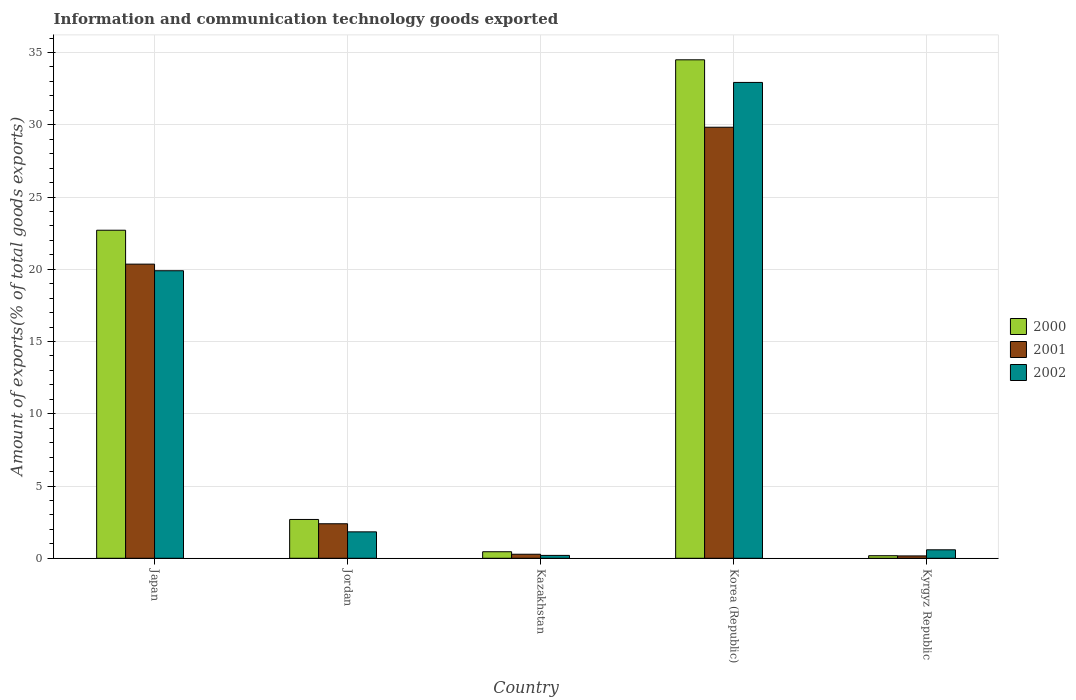What is the label of the 5th group of bars from the left?
Offer a terse response. Kyrgyz Republic. What is the amount of goods exported in 2002 in Kyrgyz Republic?
Give a very brief answer. 0.59. Across all countries, what is the maximum amount of goods exported in 2001?
Give a very brief answer. 29.83. Across all countries, what is the minimum amount of goods exported in 2001?
Your answer should be compact. 0.16. In which country was the amount of goods exported in 2001 maximum?
Offer a terse response. Korea (Republic). In which country was the amount of goods exported in 2001 minimum?
Make the answer very short. Kyrgyz Republic. What is the total amount of goods exported in 2001 in the graph?
Your response must be concise. 53.01. What is the difference between the amount of goods exported in 2001 in Kazakhstan and that in Korea (Republic)?
Ensure brevity in your answer.  -29.55. What is the difference between the amount of goods exported in 2002 in Kazakhstan and the amount of goods exported in 2001 in Korea (Republic)?
Provide a succinct answer. -29.63. What is the average amount of goods exported in 2002 per country?
Provide a short and direct response. 11.09. What is the difference between the amount of goods exported of/in 2002 and amount of goods exported of/in 2001 in Kyrgyz Republic?
Provide a succinct answer. 0.42. What is the ratio of the amount of goods exported in 2002 in Japan to that in Kazakhstan?
Give a very brief answer. 99.92. Is the difference between the amount of goods exported in 2002 in Japan and Jordan greater than the difference between the amount of goods exported in 2001 in Japan and Jordan?
Keep it short and to the point. Yes. What is the difference between the highest and the second highest amount of goods exported in 2000?
Keep it short and to the point. 31.81. What is the difference between the highest and the lowest amount of goods exported in 2000?
Keep it short and to the point. 34.32. In how many countries, is the amount of goods exported in 2002 greater than the average amount of goods exported in 2002 taken over all countries?
Keep it short and to the point. 2. What does the 1st bar from the left in Kazakhstan represents?
Provide a succinct answer. 2000. What does the 1st bar from the right in Japan represents?
Your answer should be compact. 2002. How many bars are there?
Give a very brief answer. 15. How many countries are there in the graph?
Your answer should be compact. 5. Are the values on the major ticks of Y-axis written in scientific E-notation?
Your answer should be very brief. No. Does the graph contain any zero values?
Your response must be concise. No. Does the graph contain grids?
Make the answer very short. Yes. Where does the legend appear in the graph?
Provide a short and direct response. Center right. What is the title of the graph?
Your response must be concise. Information and communication technology goods exported. What is the label or title of the Y-axis?
Provide a short and direct response. Amount of exports(% of total goods exports). What is the Amount of exports(% of total goods exports) of 2000 in Japan?
Offer a very short reply. 22.7. What is the Amount of exports(% of total goods exports) of 2001 in Japan?
Keep it short and to the point. 20.36. What is the Amount of exports(% of total goods exports) of 2002 in Japan?
Your response must be concise. 19.9. What is the Amount of exports(% of total goods exports) in 2000 in Jordan?
Your response must be concise. 2.69. What is the Amount of exports(% of total goods exports) of 2001 in Jordan?
Your answer should be compact. 2.39. What is the Amount of exports(% of total goods exports) of 2002 in Jordan?
Keep it short and to the point. 1.83. What is the Amount of exports(% of total goods exports) of 2000 in Kazakhstan?
Keep it short and to the point. 0.45. What is the Amount of exports(% of total goods exports) of 2001 in Kazakhstan?
Offer a terse response. 0.28. What is the Amount of exports(% of total goods exports) in 2002 in Kazakhstan?
Offer a very short reply. 0.2. What is the Amount of exports(% of total goods exports) in 2000 in Korea (Republic)?
Give a very brief answer. 34.5. What is the Amount of exports(% of total goods exports) of 2001 in Korea (Republic)?
Provide a short and direct response. 29.83. What is the Amount of exports(% of total goods exports) in 2002 in Korea (Republic)?
Your response must be concise. 32.93. What is the Amount of exports(% of total goods exports) of 2000 in Kyrgyz Republic?
Your response must be concise. 0.18. What is the Amount of exports(% of total goods exports) of 2001 in Kyrgyz Republic?
Keep it short and to the point. 0.16. What is the Amount of exports(% of total goods exports) of 2002 in Kyrgyz Republic?
Keep it short and to the point. 0.59. Across all countries, what is the maximum Amount of exports(% of total goods exports) in 2000?
Make the answer very short. 34.5. Across all countries, what is the maximum Amount of exports(% of total goods exports) in 2001?
Your answer should be very brief. 29.83. Across all countries, what is the maximum Amount of exports(% of total goods exports) of 2002?
Ensure brevity in your answer.  32.93. Across all countries, what is the minimum Amount of exports(% of total goods exports) of 2000?
Ensure brevity in your answer.  0.18. Across all countries, what is the minimum Amount of exports(% of total goods exports) in 2001?
Your answer should be very brief. 0.16. Across all countries, what is the minimum Amount of exports(% of total goods exports) in 2002?
Your answer should be very brief. 0.2. What is the total Amount of exports(% of total goods exports) of 2000 in the graph?
Ensure brevity in your answer.  60.51. What is the total Amount of exports(% of total goods exports) in 2001 in the graph?
Make the answer very short. 53.01. What is the total Amount of exports(% of total goods exports) in 2002 in the graph?
Give a very brief answer. 55.44. What is the difference between the Amount of exports(% of total goods exports) in 2000 in Japan and that in Jordan?
Offer a terse response. 20.02. What is the difference between the Amount of exports(% of total goods exports) of 2001 in Japan and that in Jordan?
Give a very brief answer. 17.97. What is the difference between the Amount of exports(% of total goods exports) in 2002 in Japan and that in Jordan?
Your response must be concise. 18.07. What is the difference between the Amount of exports(% of total goods exports) of 2000 in Japan and that in Kazakhstan?
Give a very brief answer. 22.25. What is the difference between the Amount of exports(% of total goods exports) in 2001 in Japan and that in Kazakhstan?
Give a very brief answer. 20.08. What is the difference between the Amount of exports(% of total goods exports) of 2002 in Japan and that in Kazakhstan?
Keep it short and to the point. 19.7. What is the difference between the Amount of exports(% of total goods exports) in 2000 in Japan and that in Korea (Republic)?
Your answer should be very brief. -11.79. What is the difference between the Amount of exports(% of total goods exports) in 2001 in Japan and that in Korea (Republic)?
Provide a short and direct response. -9.47. What is the difference between the Amount of exports(% of total goods exports) in 2002 in Japan and that in Korea (Republic)?
Make the answer very short. -13.03. What is the difference between the Amount of exports(% of total goods exports) of 2000 in Japan and that in Kyrgyz Republic?
Keep it short and to the point. 22.53. What is the difference between the Amount of exports(% of total goods exports) of 2001 in Japan and that in Kyrgyz Republic?
Provide a short and direct response. 20.19. What is the difference between the Amount of exports(% of total goods exports) of 2002 in Japan and that in Kyrgyz Republic?
Your response must be concise. 19.31. What is the difference between the Amount of exports(% of total goods exports) of 2000 in Jordan and that in Kazakhstan?
Provide a succinct answer. 2.23. What is the difference between the Amount of exports(% of total goods exports) in 2001 in Jordan and that in Kazakhstan?
Keep it short and to the point. 2.11. What is the difference between the Amount of exports(% of total goods exports) of 2002 in Jordan and that in Kazakhstan?
Your answer should be very brief. 1.63. What is the difference between the Amount of exports(% of total goods exports) of 2000 in Jordan and that in Korea (Republic)?
Offer a terse response. -31.81. What is the difference between the Amount of exports(% of total goods exports) in 2001 in Jordan and that in Korea (Republic)?
Your response must be concise. -27.44. What is the difference between the Amount of exports(% of total goods exports) in 2002 in Jordan and that in Korea (Republic)?
Provide a short and direct response. -31.1. What is the difference between the Amount of exports(% of total goods exports) in 2000 in Jordan and that in Kyrgyz Republic?
Ensure brevity in your answer.  2.51. What is the difference between the Amount of exports(% of total goods exports) in 2001 in Jordan and that in Kyrgyz Republic?
Keep it short and to the point. 2.23. What is the difference between the Amount of exports(% of total goods exports) of 2002 in Jordan and that in Kyrgyz Republic?
Your response must be concise. 1.24. What is the difference between the Amount of exports(% of total goods exports) of 2000 in Kazakhstan and that in Korea (Republic)?
Offer a very short reply. -34.04. What is the difference between the Amount of exports(% of total goods exports) in 2001 in Kazakhstan and that in Korea (Republic)?
Your answer should be compact. -29.55. What is the difference between the Amount of exports(% of total goods exports) in 2002 in Kazakhstan and that in Korea (Republic)?
Make the answer very short. -32.73. What is the difference between the Amount of exports(% of total goods exports) of 2000 in Kazakhstan and that in Kyrgyz Republic?
Your answer should be very brief. 0.28. What is the difference between the Amount of exports(% of total goods exports) of 2001 in Kazakhstan and that in Kyrgyz Republic?
Offer a very short reply. 0.12. What is the difference between the Amount of exports(% of total goods exports) in 2002 in Kazakhstan and that in Kyrgyz Republic?
Provide a succinct answer. -0.39. What is the difference between the Amount of exports(% of total goods exports) of 2000 in Korea (Republic) and that in Kyrgyz Republic?
Your answer should be compact. 34.32. What is the difference between the Amount of exports(% of total goods exports) in 2001 in Korea (Republic) and that in Kyrgyz Republic?
Offer a very short reply. 29.67. What is the difference between the Amount of exports(% of total goods exports) of 2002 in Korea (Republic) and that in Kyrgyz Republic?
Offer a very short reply. 32.34. What is the difference between the Amount of exports(% of total goods exports) of 2000 in Japan and the Amount of exports(% of total goods exports) of 2001 in Jordan?
Provide a short and direct response. 20.31. What is the difference between the Amount of exports(% of total goods exports) in 2000 in Japan and the Amount of exports(% of total goods exports) in 2002 in Jordan?
Provide a succinct answer. 20.87. What is the difference between the Amount of exports(% of total goods exports) in 2001 in Japan and the Amount of exports(% of total goods exports) in 2002 in Jordan?
Ensure brevity in your answer.  18.53. What is the difference between the Amount of exports(% of total goods exports) of 2000 in Japan and the Amount of exports(% of total goods exports) of 2001 in Kazakhstan?
Your answer should be very brief. 22.42. What is the difference between the Amount of exports(% of total goods exports) of 2000 in Japan and the Amount of exports(% of total goods exports) of 2002 in Kazakhstan?
Give a very brief answer. 22.5. What is the difference between the Amount of exports(% of total goods exports) in 2001 in Japan and the Amount of exports(% of total goods exports) in 2002 in Kazakhstan?
Offer a terse response. 20.16. What is the difference between the Amount of exports(% of total goods exports) of 2000 in Japan and the Amount of exports(% of total goods exports) of 2001 in Korea (Republic)?
Provide a succinct answer. -7.13. What is the difference between the Amount of exports(% of total goods exports) of 2000 in Japan and the Amount of exports(% of total goods exports) of 2002 in Korea (Republic)?
Offer a very short reply. -10.23. What is the difference between the Amount of exports(% of total goods exports) of 2001 in Japan and the Amount of exports(% of total goods exports) of 2002 in Korea (Republic)?
Provide a succinct answer. -12.57. What is the difference between the Amount of exports(% of total goods exports) of 2000 in Japan and the Amount of exports(% of total goods exports) of 2001 in Kyrgyz Republic?
Offer a very short reply. 22.54. What is the difference between the Amount of exports(% of total goods exports) in 2000 in Japan and the Amount of exports(% of total goods exports) in 2002 in Kyrgyz Republic?
Your answer should be very brief. 22.12. What is the difference between the Amount of exports(% of total goods exports) in 2001 in Japan and the Amount of exports(% of total goods exports) in 2002 in Kyrgyz Republic?
Offer a very short reply. 19.77. What is the difference between the Amount of exports(% of total goods exports) of 2000 in Jordan and the Amount of exports(% of total goods exports) of 2001 in Kazakhstan?
Make the answer very short. 2.41. What is the difference between the Amount of exports(% of total goods exports) of 2000 in Jordan and the Amount of exports(% of total goods exports) of 2002 in Kazakhstan?
Your answer should be compact. 2.49. What is the difference between the Amount of exports(% of total goods exports) of 2001 in Jordan and the Amount of exports(% of total goods exports) of 2002 in Kazakhstan?
Your answer should be compact. 2.19. What is the difference between the Amount of exports(% of total goods exports) in 2000 in Jordan and the Amount of exports(% of total goods exports) in 2001 in Korea (Republic)?
Offer a very short reply. -27.14. What is the difference between the Amount of exports(% of total goods exports) in 2000 in Jordan and the Amount of exports(% of total goods exports) in 2002 in Korea (Republic)?
Provide a succinct answer. -30.24. What is the difference between the Amount of exports(% of total goods exports) in 2001 in Jordan and the Amount of exports(% of total goods exports) in 2002 in Korea (Republic)?
Ensure brevity in your answer.  -30.54. What is the difference between the Amount of exports(% of total goods exports) in 2000 in Jordan and the Amount of exports(% of total goods exports) in 2001 in Kyrgyz Republic?
Provide a short and direct response. 2.52. What is the difference between the Amount of exports(% of total goods exports) in 2000 in Jordan and the Amount of exports(% of total goods exports) in 2002 in Kyrgyz Republic?
Give a very brief answer. 2.1. What is the difference between the Amount of exports(% of total goods exports) of 2001 in Jordan and the Amount of exports(% of total goods exports) of 2002 in Kyrgyz Republic?
Ensure brevity in your answer.  1.8. What is the difference between the Amount of exports(% of total goods exports) in 2000 in Kazakhstan and the Amount of exports(% of total goods exports) in 2001 in Korea (Republic)?
Offer a terse response. -29.38. What is the difference between the Amount of exports(% of total goods exports) of 2000 in Kazakhstan and the Amount of exports(% of total goods exports) of 2002 in Korea (Republic)?
Give a very brief answer. -32.48. What is the difference between the Amount of exports(% of total goods exports) in 2001 in Kazakhstan and the Amount of exports(% of total goods exports) in 2002 in Korea (Republic)?
Ensure brevity in your answer.  -32.65. What is the difference between the Amount of exports(% of total goods exports) of 2000 in Kazakhstan and the Amount of exports(% of total goods exports) of 2001 in Kyrgyz Republic?
Your answer should be very brief. 0.29. What is the difference between the Amount of exports(% of total goods exports) of 2000 in Kazakhstan and the Amount of exports(% of total goods exports) of 2002 in Kyrgyz Republic?
Your answer should be very brief. -0.13. What is the difference between the Amount of exports(% of total goods exports) of 2001 in Kazakhstan and the Amount of exports(% of total goods exports) of 2002 in Kyrgyz Republic?
Offer a very short reply. -0.31. What is the difference between the Amount of exports(% of total goods exports) of 2000 in Korea (Republic) and the Amount of exports(% of total goods exports) of 2001 in Kyrgyz Republic?
Your answer should be compact. 34.33. What is the difference between the Amount of exports(% of total goods exports) in 2000 in Korea (Republic) and the Amount of exports(% of total goods exports) in 2002 in Kyrgyz Republic?
Provide a succinct answer. 33.91. What is the difference between the Amount of exports(% of total goods exports) of 2001 in Korea (Republic) and the Amount of exports(% of total goods exports) of 2002 in Kyrgyz Republic?
Offer a terse response. 29.24. What is the average Amount of exports(% of total goods exports) of 2000 per country?
Ensure brevity in your answer.  12.1. What is the average Amount of exports(% of total goods exports) in 2001 per country?
Your answer should be very brief. 10.6. What is the average Amount of exports(% of total goods exports) in 2002 per country?
Your answer should be compact. 11.09. What is the difference between the Amount of exports(% of total goods exports) in 2000 and Amount of exports(% of total goods exports) in 2001 in Japan?
Provide a short and direct response. 2.35. What is the difference between the Amount of exports(% of total goods exports) in 2000 and Amount of exports(% of total goods exports) in 2002 in Japan?
Offer a terse response. 2.8. What is the difference between the Amount of exports(% of total goods exports) in 2001 and Amount of exports(% of total goods exports) in 2002 in Japan?
Provide a short and direct response. 0.46. What is the difference between the Amount of exports(% of total goods exports) of 2000 and Amount of exports(% of total goods exports) of 2001 in Jordan?
Provide a short and direct response. 0.3. What is the difference between the Amount of exports(% of total goods exports) in 2000 and Amount of exports(% of total goods exports) in 2002 in Jordan?
Offer a terse response. 0.86. What is the difference between the Amount of exports(% of total goods exports) in 2001 and Amount of exports(% of total goods exports) in 2002 in Jordan?
Provide a succinct answer. 0.56. What is the difference between the Amount of exports(% of total goods exports) in 2000 and Amount of exports(% of total goods exports) in 2001 in Kazakhstan?
Offer a terse response. 0.17. What is the difference between the Amount of exports(% of total goods exports) of 2000 and Amount of exports(% of total goods exports) of 2002 in Kazakhstan?
Your answer should be very brief. 0.25. What is the difference between the Amount of exports(% of total goods exports) in 2001 and Amount of exports(% of total goods exports) in 2002 in Kazakhstan?
Offer a terse response. 0.08. What is the difference between the Amount of exports(% of total goods exports) of 2000 and Amount of exports(% of total goods exports) of 2001 in Korea (Republic)?
Provide a short and direct response. 4.67. What is the difference between the Amount of exports(% of total goods exports) in 2000 and Amount of exports(% of total goods exports) in 2002 in Korea (Republic)?
Offer a terse response. 1.57. What is the difference between the Amount of exports(% of total goods exports) in 2001 and Amount of exports(% of total goods exports) in 2002 in Korea (Republic)?
Offer a terse response. -3.1. What is the difference between the Amount of exports(% of total goods exports) in 2000 and Amount of exports(% of total goods exports) in 2001 in Kyrgyz Republic?
Your response must be concise. 0.01. What is the difference between the Amount of exports(% of total goods exports) in 2000 and Amount of exports(% of total goods exports) in 2002 in Kyrgyz Republic?
Give a very brief answer. -0.41. What is the difference between the Amount of exports(% of total goods exports) in 2001 and Amount of exports(% of total goods exports) in 2002 in Kyrgyz Republic?
Ensure brevity in your answer.  -0.42. What is the ratio of the Amount of exports(% of total goods exports) in 2000 in Japan to that in Jordan?
Ensure brevity in your answer.  8.45. What is the ratio of the Amount of exports(% of total goods exports) in 2001 in Japan to that in Jordan?
Offer a terse response. 8.52. What is the ratio of the Amount of exports(% of total goods exports) of 2002 in Japan to that in Jordan?
Offer a very short reply. 10.88. What is the ratio of the Amount of exports(% of total goods exports) in 2000 in Japan to that in Kazakhstan?
Ensure brevity in your answer.  50.23. What is the ratio of the Amount of exports(% of total goods exports) in 2001 in Japan to that in Kazakhstan?
Give a very brief answer. 72.95. What is the ratio of the Amount of exports(% of total goods exports) of 2002 in Japan to that in Kazakhstan?
Make the answer very short. 99.92. What is the ratio of the Amount of exports(% of total goods exports) of 2000 in Japan to that in Korea (Republic)?
Provide a short and direct response. 0.66. What is the ratio of the Amount of exports(% of total goods exports) in 2001 in Japan to that in Korea (Republic)?
Your answer should be very brief. 0.68. What is the ratio of the Amount of exports(% of total goods exports) of 2002 in Japan to that in Korea (Republic)?
Offer a very short reply. 0.6. What is the ratio of the Amount of exports(% of total goods exports) of 2000 in Japan to that in Kyrgyz Republic?
Your answer should be very brief. 128.57. What is the ratio of the Amount of exports(% of total goods exports) in 2001 in Japan to that in Kyrgyz Republic?
Provide a short and direct response. 125.24. What is the ratio of the Amount of exports(% of total goods exports) in 2002 in Japan to that in Kyrgyz Republic?
Keep it short and to the point. 33.96. What is the ratio of the Amount of exports(% of total goods exports) of 2000 in Jordan to that in Kazakhstan?
Provide a succinct answer. 5.94. What is the ratio of the Amount of exports(% of total goods exports) of 2001 in Jordan to that in Kazakhstan?
Provide a short and direct response. 8.56. What is the ratio of the Amount of exports(% of total goods exports) of 2002 in Jordan to that in Kazakhstan?
Your response must be concise. 9.18. What is the ratio of the Amount of exports(% of total goods exports) in 2000 in Jordan to that in Korea (Republic)?
Ensure brevity in your answer.  0.08. What is the ratio of the Amount of exports(% of total goods exports) in 2001 in Jordan to that in Korea (Republic)?
Make the answer very short. 0.08. What is the ratio of the Amount of exports(% of total goods exports) of 2002 in Jordan to that in Korea (Republic)?
Ensure brevity in your answer.  0.06. What is the ratio of the Amount of exports(% of total goods exports) of 2000 in Jordan to that in Kyrgyz Republic?
Give a very brief answer. 15.21. What is the ratio of the Amount of exports(% of total goods exports) in 2001 in Jordan to that in Kyrgyz Republic?
Your answer should be very brief. 14.7. What is the ratio of the Amount of exports(% of total goods exports) in 2002 in Jordan to that in Kyrgyz Republic?
Give a very brief answer. 3.12. What is the ratio of the Amount of exports(% of total goods exports) in 2000 in Kazakhstan to that in Korea (Republic)?
Keep it short and to the point. 0.01. What is the ratio of the Amount of exports(% of total goods exports) in 2001 in Kazakhstan to that in Korea (Republic)?
Your response must be concise. 0.01. What is the ratio of the Amount of exports(% of total goods exports) of 2002 in Kazakhstan to that in Korea (Republic)?
Make the answer very short. 0.01. What is the ratio of the Amount of exports(% of total goods exports) in 2000 in Kazakhstan to that in Kyrgyz Republic?
Give a very brief answer. 2.56. What is the ratio of the Amount of exports(% of total goods exports) in 2001 in Kazakhstan to that in Kyrgyz Republic?
Your response must be concise. 1.72. What is the ratio of the Amount of exports(% of total goods exports) in 2002 in Kazakhstan to that in Kyrgyz Republic?
Offer a very short reply. 0.34. What is the ratio of the Amount of exports(% of total goods exports) in 2000 in Korea (Republic) to that in Kyrgyz Republic?
Keep it short and to the point. 195.36. What is the ratio of the Amount of exports(% of total goods exports) in 2001 in Korea (Republic) to that in Kyrgyz Republic?
Provide a short and direct response. 183.52. What is the ratio of the Amount of exports(% of total goods exports) of 2002 in Korea (Republic) to that in Kyrgyz Republic?
Provide a succinct answer. 56.21. What is the difference between the highest and the second highest Amount of exports(% of total goods exports) of 2000?
Provide a short and direct response. 11.79. What is the difference between the highest and the second highest Amount of exports(% of total goods exports) in 2001?
Make the answer very short. 9.47. What is the difference between the highest and the second highest Amount of exports(% of total goods exports) of 2002?
Give a very brief answer. 13.03. What is the difference between the highest and the lowest Amount of exports(% of total goods exports) of 2000?
Offer a very short reply. 34.32. What is the difference between the highest and the lowest Amount of exports(% of total goods exports) in 2001?
Your answer should be compact. 29.67. What is the difference between the highest and the lowest Amount of exports(% of total goods exports) in 2002?
Give a very brief answer. 32.73. 